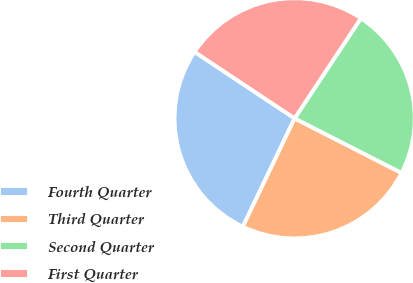Convert chart. <chart><loc_0><loc_0><loc_500><loc_500><pie_chart><fcel>Fourth Quarter<fcel>Third Quarter<fcel>Second Quarter<fcel>First Quarter<nl><fcel>27.24%<fcel>24.58%<fcel>23.2%<fcel>24.98%<nl></chart> 